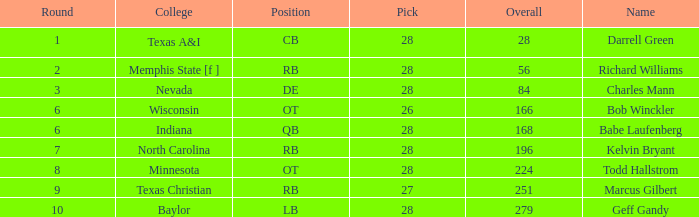What is the highest pick of the player from texas a&i with an overall less than 28? None. 